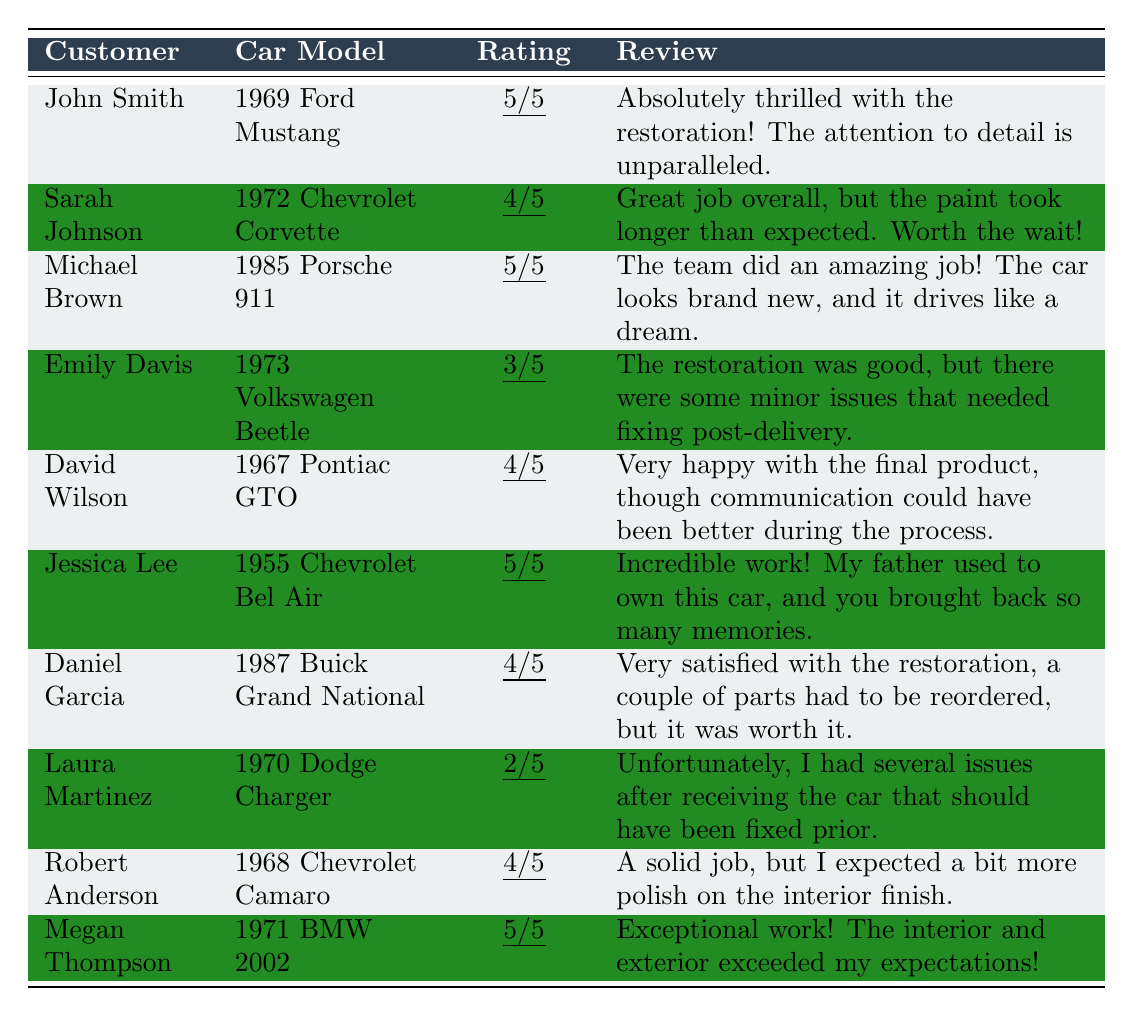What is the highest customer rating given in the table? The highest rating listed is 5, awarded to John Smith, Michael Brown, Jessica Lee, and Megan Thompson.
Answer: 5 How many customers rated their restoration project 4 out of 5? The customers who rated 4 are Sarah Johnson, David Wilson, and Daniel Garcia. That is a total of 3 customers.
Answer: 3 Did any customer give a rating of 2 out of 5? Yes, Laura Martinez rated her restoration project 2 out of 5.
Answer: Yes Which car model had the lowest customer rating? The car model with the lowest rating is the 1970 Dodge Charger, rated 2 out of 5 by Laura Martinez.
Answer: 1970 Dodge Charger What is the average rating of all restoration projects? The total ratings are (5 + 4 + 5 + 3 + 4 + 5 + 4 + 2 + 4 + 5) = 45, and there are 10 projects. So, the average rating is 45/10 = 4.5.
Answer: 4.5 How many customers expressed satisfaction in their reviews? Customers who expressed satisfaction are those with ratings of 4 or 5: John Smith, Michael Brown, Jessica Lee, Megan Thompson, Sarah Johnson, David Wilson, and Daniel Garcia. That totals 7 satisfied customers.
Answer: 7 What percentage of customers rated their restoration project positively (4 or 5 stars)? There are 7 ratings of 4 or 5 stars out of 10 total ratings, which is (7/10)*100 = 70%.
Answer: 70% Did any customers mention communication issues in their reviews? Yes, David Wilson mentioned that communication could have been better during the restoration process.
Answer: Yes What is the total number of unique car models mentioned in the feedback? The unique car models are: 1969 Ford Mustang, 1972 Chevrolet Corvette, 1985 Porsche 911, 1973 Volkswagen Beetle, 1967 Pontiac GTO, 1955 Chevrolet Bel Air, 1987 Buick Grand National, 1970 Dodge Charger, 1968 Chevrolet Camaro, and 1971 BMW 2002. That makes 10 unique car models.
Answer: 10 How many reviews indicated that there were issues after delivery? The reviews that indicated issues after delivery are from Emily Davis and Laura Martinez. So there are 2 reviews that mention issues.
Answer: 2 